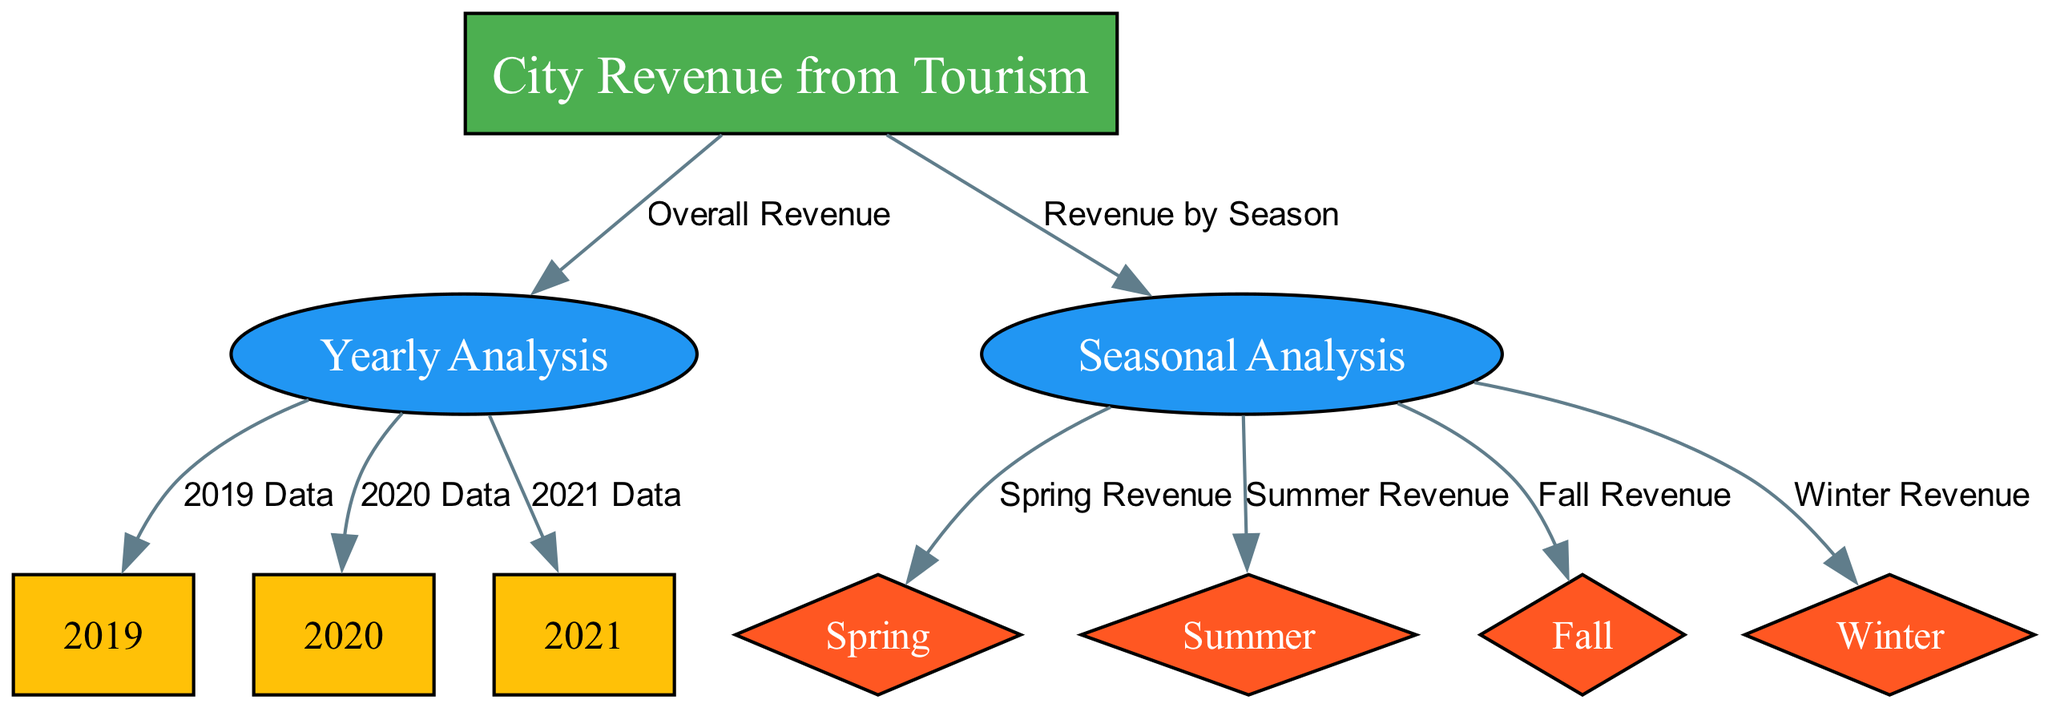What is the main category represented in the diagram? The diagram's main category is indicated by the label of the main node, which is "City Revenue from Tourism." It is the starting point of the diagram.
Answer: City Revenue from Tourism How many years are analyzed in this diagram? The diagram includes three year nodes: 2019, 2020, and 2021. By counting these nodes, we can determine the number of years analyzed.
Answer: Three What are the four seasons shown in the diagram? The seasons represented in the diagram as nodes are Spring, Summer, Fall, and Winter. They display the seasonal revenue breakdown.
Answer: Spring, Summer, Fall, Winter Which year has the most revenue analysis connections? The yearly nodes for 2019, 2020, and 2021 are connected to the main yearly analysis node, suggesting each year has the same number of revenue analysis connections. Thus, there is no single year with the most connections.
Answer: All Which season has a direct connection to "Revenue by Season"? The seasonal analysis node "Revenue by Season" has direct outgoing edges connecting to Spring, Summer, Fall, and Winter nodes, indicating all seasons are represented.
Answer: All seasons In what structure is the yearly data categorized? The yearly data is organized hierarchically as sub-nodes under the main node "Yearly Analysis," each representing a specific year.
Answer: Hierarchically under Yearly Analysis What type of relationships connect the nodes in the diagram? The nodes are connected through directed edges, indicating a flowing relationship from the main category to subcategories and then to specific seasonal and yearly data.
Answer: Directed edges Which type of revenue analysis does "Fall" fall under? The "Fall" node is categorized under the "Seasonal Analysis" node, indicating it is part of the analysis that focuses on seasonal trends in tourism revenue.
Answer: Seasonal Analysis How many edges originate from the seasonal analysis node? The "Seasonal Analysis" node connects to all four seasons (Spring, Summer, Fall, Winter), resulting in a total of four edges that originate from it.
Answer: Four 